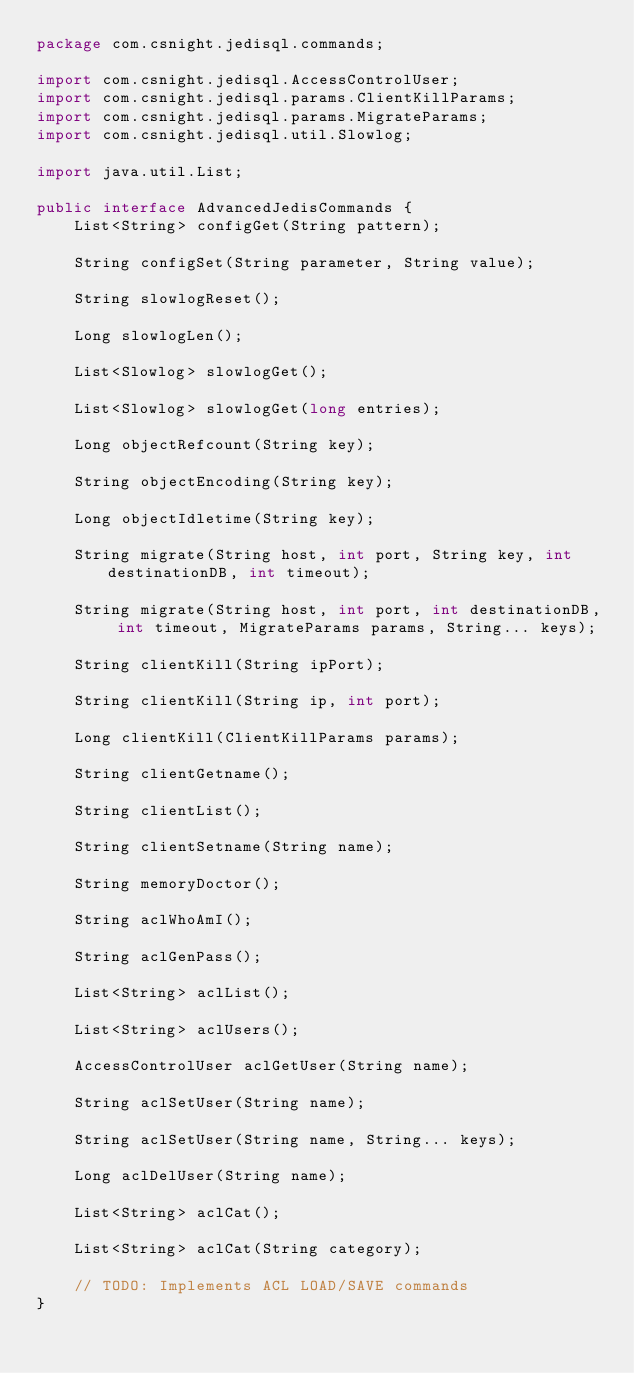<code> <loc_0><loc_0><loc_500><loc_500><_Java_>package com.csnight.jedisql.commands;

import com.csnight.jedisql.AccessControlUser;
import com.csnight.jedisql.params.ClientKillParams;
import com.csnight.jedisql.params.MigrateParams;
import com.csnight.jedisql.util.Slowlog;

import java.util.List;

public interface AdvancedJedisCommands {
    List<String> configGet(String pattern);

    String configSet(String parameter, String value);

    String slowlogReset();

    Long slowlogLen();

    List<Slowlog> slowlogGet();

    List<Slowlog> slowlogGet(long entries);

    Long objectRefcount(String key);

    String objectEncoding(String key);

    Long objectIdletime(String key);

    String migrate(String host, int port, String key, int destinationDB, int timeout);

    String migrate(String host, int port, int destinationDB, int timeout, MigrateParams params, String... keys);

    String clientKill(String ipPort);

    String clientKill(String ip, int port);

    Long clientKill(ClientKillParams params);

    String clientGetname();

    String clientList();

    String clientSetname(String name);

    String memoryDoctor();

    String aclWhoAmI();

    String aclGenPass();

    List<String> aclList();

    List<String> aclUsers();

    AccessControlUser aclGetUser(String name);

    String aclSetUser(String name);

    String aclSetUser(String name, String... keys);

    Long aclDelUser(String name);

    List<String> aclCat();

    List<String> aclCat(String category);

    // TODO: Implements ACL LOAD/SAVE commands
}
</code> 